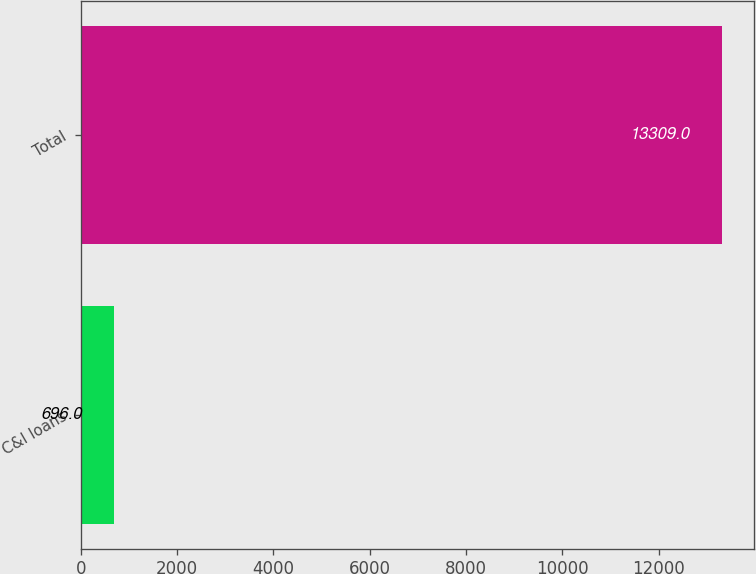<chart> <loc_0><loc_0><loc_500><loc_500><bar_chart><fcel>C&I loans<fcel>Total<nl><fcel>696<fcel>13309<nl></chart> 